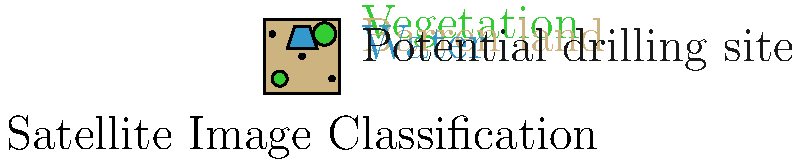Based on the satellite image classification shown, which feature is most likely to indicate a potential drilling site for oil and gas exploration? To identify potential drilling sites from satellite imagery, we need to consider several factors:

1. Geological features: Oil and gas deposits are often associated with specific geological formations.
2. Land cover: Drilling sites are typically located in areas with minimal vegetation and away from water bodies.
3. Existing infrastructure: The presence of roads or other structures might indicate previous exploration activities.

In this classified image:

a) Green areas represent vegetation, which are less likely to be drilling sites due to environmental concerns and the need for land clearing.
b) Blue areas represent water bodies, which are not suitable for land-based drilling operations.
c) Tan areas represent barren land, which could be potential sites as they require minimal land preparation.
d) Black dots represent areas identified as potential drilling sites based on spectral and textural analysis of the satellite imagery.

The black dots are the most likely indicators of potential drilling sites because:
1. They are located on barren land, away from vegetation and water bodies.
2. Their distinct spectral signature in the imagery suggests the presence of minerals or surface features associated with oil and gas deposits.
3. They are small and isolated, which is typical for initial exploration sites.

Therefore, the black dots, representing areas with specific spectral and textural characteristics indicative of potential oil and gas deposits, are the most likely feature to indicate potential drilling sites in this classified satellite image.
Answer: Black dots 